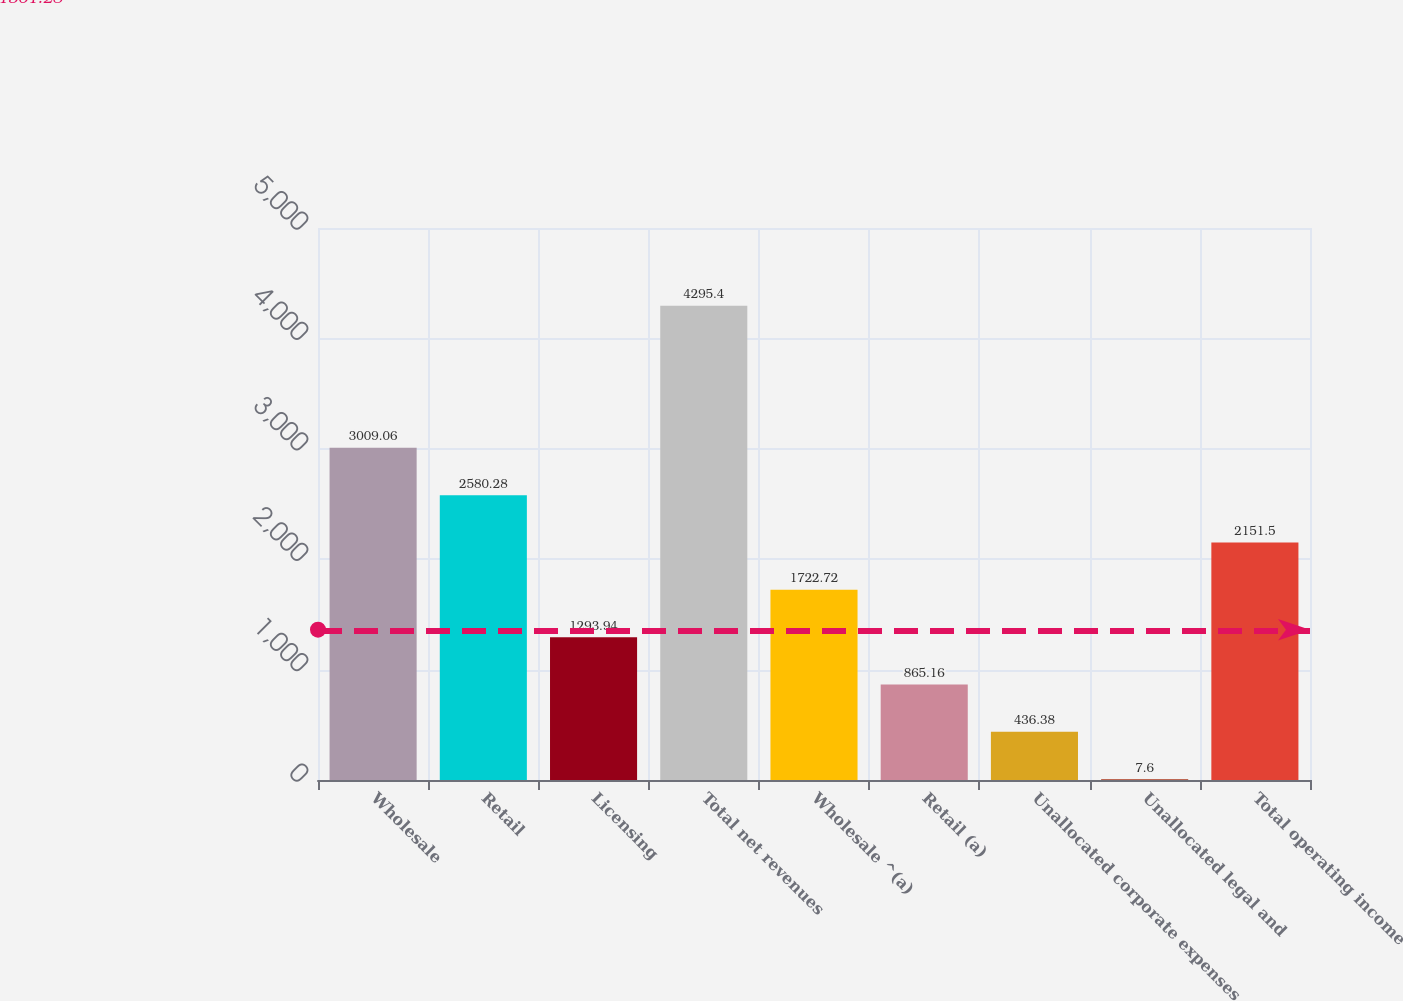Convert chart to OTSL. <chart><loc_0><loc_0><loc_500><loc_500><bar_chart><fcel>Wholesale<fcel>Retail<fcel>Licensing<fcel>Total net revenues<fcel>Wholesale ^(a)<fcel>Retail (a)<fcel>Unallocated corporate expenses<fcel>Unallocated legal and<fcel>Total operating income<nl><fcel>3009.06<fcel>2580.28<fcel>1293.94<fcel>4295.4<fcel>1722.72<fcel>865.16<fcel>436.38<fcel>7.6<fcel>2151.5<nl></chart> 